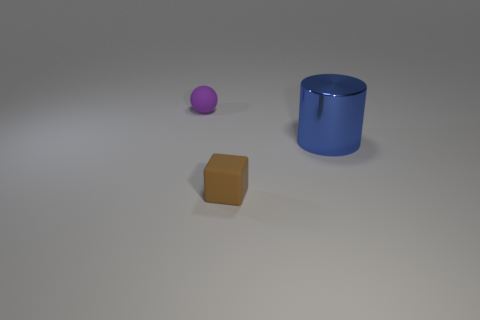Is there anything else that has the same material as the cylinder?
Your answer should be compact. No. Is there anything else that is the same size as the metallic cylinder?
Offer a terse response. No. Is there any other thing that has the same shape as the large blue metal thing?
Give a very brief answer. No. Is the shape of the metallic object the same as the small rubber object in front of the blue cylinder?
Keep it short and to the point. No. How many other things are there of the same material as the large blue cylinder?
Your answer should be very brief. 0. Does the large cylinder have the same color as the small object that is in front of the purple matte thing?
Offer a terse response. No. There is a tiny object that is in front of the tiny purple matte ball; what material is it?
Make the answer very short. Rubber. Are there any large balls that have the same color as the big cylinder?
Provide a short and direct response. No. There is a sphere that is the same size as the brown thing; what color is it?
Your answer should be very brief. Purple. What number of tiny objects are either brown rubber things or blue metal blocks?
Your answer should be very brief. 1. 